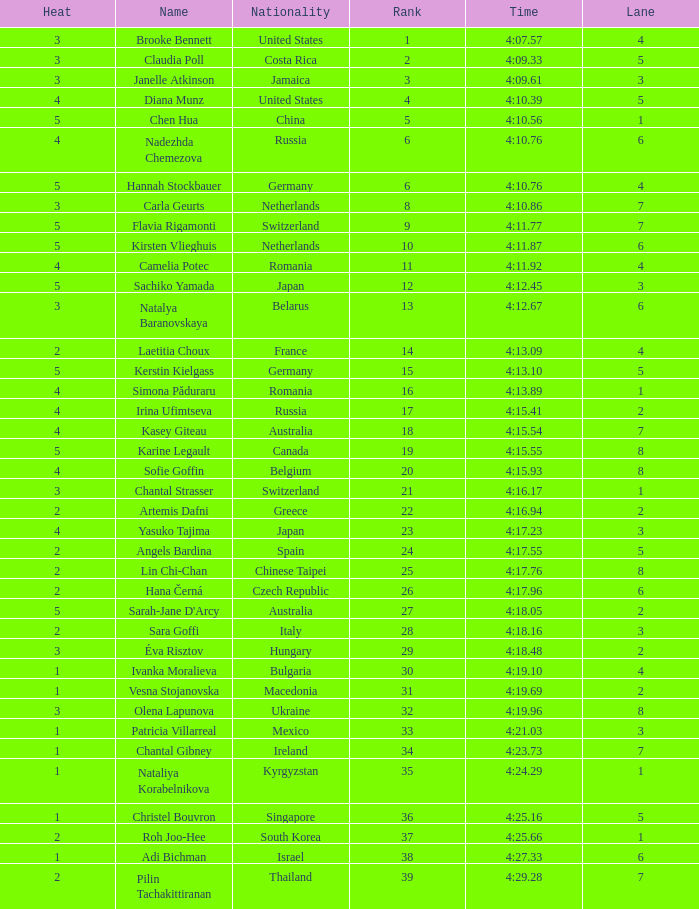Write the full table. {'header': ['Heat', 'Name', 'Nationality', 'Rank', 'Time', 'Lane'], 'rows': [['3', 'Brooke Bennett', 'United States', '1', '4:07.57', '4'], ['3', 'Claudia Poll', 'Costa Rica', '2', '4:09.33', '5'], ['3', 'Janelle Atkinson', 'Jamaica', '3', '4:09.61', '3'], ['4', 'Diana Munz', 'United States', '4', '4:10.39', '5'], ['5', 'Chen Hua', 'China', '5', '4:10.56', '1'], ['4', 'Nadezhda Chemezova', 'Russia', '6', '4:10.76', '6'], ['5', 'Hannah Stockbauer', 'Germany', '6', '4:10.76', '4'], ['3', 'Carla Geurts', 'Netherlands', '8', '4:10.86', '7'], ['5', 'Flavia Rigamonti', 'Switzerland', '9', '4:11.77', '7'], ['5', 'Kirsten Vlieghuis', 'Netherlands', '10', '4:11.87', '6'], ['4', 'Camelia Potec', 'Romania', '11', '4:11.92', '4'], ['5', 'Sachiko Yamada', 'Japan', '12', '4:12.45', '3'], ['3', 'Natalya Baranovskaya', 'Belarus', '13', '4:12.67', '6'], ['2', 'Laetitia Choux', 'France', '14', '4:13.09', '4'], ['5', 'Kerstin Kielgass', 'Germany', '15', '4:13.10', '5'], ['4', 'Simona Păduraru', 'Romania', '16', '4:13.89', '1'], ['4', 'Irina Ufimtseva', 'Russia', '17', '4:15.41', '2'], ['4', 'Kasey Giteau', 'Australia', '18', '4:15.54', '7'], ['5', 'Karine Legault', 'Canada', '19', '4:15.55', '8'], ['4', 'Sofie Goffin', 'Belgium', '20', '4:15.93', '8'], ['3', 'Chantal Strasser', 'Switzerland', '21', '4:16.17', '1'], ['2', 'Artemis Dafni', 'Greece', '22', '4:16.94', '2'], ['4', 'Yasuko Tajima', 'Japan', '23', '4:17.23', '3'], ['2', 'Angels Bardina', 'Spain', '24', '4:17.55', '5'], ['2', 'Lin Chi-Chan', 'Chinese Taipei', '25', '4:17.76', '8'], ['2', 'Hana Černá', 'Czech Republic', '26', '4:17.96', '6'], ['5', "Sarah-Jane D'Arcy", 'Australia', '27', '4:18.05', '2'], ['2', 'Sara Goffi', 'Italy', '28', '4:18.16', '3'], ['3', 'Éva Risztov', 'Hungary', '29', '4:18.48', '2'], ['1', 'Ivanka Moralieva', 'Bulgaria', '30', '4:19.10', '4'], ['1', 'Vesna Stojanovska', 'Macedonia', '31', '4:19.69', '2'], ['3', 'Olena Lapunova', 'Ukraine', '32', '4:19.96', '8'], ['1', 'Patricia Villarreal', 'Mexico', '33', '4:21.03', '3'], ['1', 'Chantal Gibney', 'Ireland', '34', '4:23.73', '7'], ['1', 'Nataliya Korabelnikova', 'Kyrgyzstan', '35', '4:24.29', '1'], ['1', 'Christel Bouvron', 'Singapore', '36', '4:25.16', '5'], ['2', 'Roh Joo-Hee', 'South Korea', '37', '4:25.66', '1'], ['1', 'Adi Bichman', 'Israel', '38', '4:27.33', '6'], ['2', 'Pilin Tachakittiranan', 'Thailand', '39', '4:29.28', '7']]} Name the total number of lane for brooke bennett and rank less than 1 0.0. 